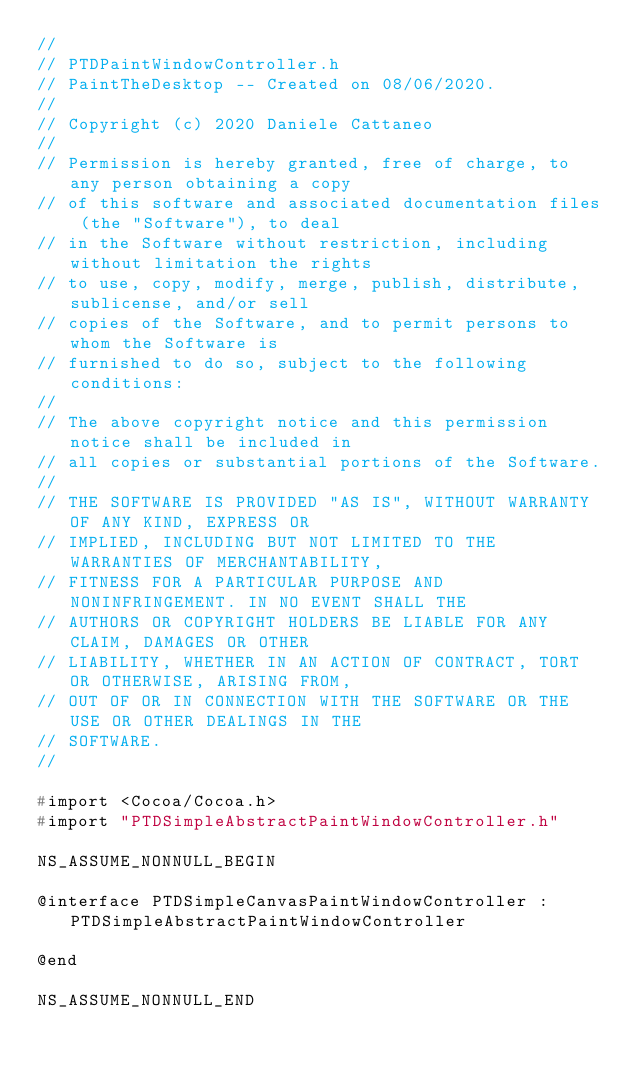Convert code to text. <code><loc_0><loc_0><loc_500><loc_500><_C_>//
// PTDPaintWindowController.h
// PaintTheDesktop -- Created on 08/06/2020.
//
// Copyright (c) 2020 Daniele Cattaneo
//
// Permission is hereby granted, free of charge, to any person obtaining a copy
// of this software and associated documentation files (the "Software"), to deal
// in the Software without restriction, including without limitation the rights
// to use, copy, modify, merge, publish, distribute, sublicense, and/or sell
// copies of the Software, and to permit persons to whom the Software is
// furnished to do so, subject to the following conditions:
//
// The above copyright notice and this permission notice shall be included in
// all copies or substantial portions of the Software.
//
// THE SOFTWARE IS PROVIDED "AS IS", WITHOUT WARRANTY OF ANY KIND, EXPRESS OR
// IMPLIED, INCLUDING BUT NOT LIMITED TO THE WARRANTIES OF MERCHANTABILITY,
// FITNESS FOR A PARTICULAR PURPOSE AND NONINFRINGEMENT. IN NO EVENT SHALL THE
// AUTHORS OR COPYRIGHT HOLDERS BE LIABLE FOR ANY CLAIM, DAMAGES OR OTHER
// LIABILITY, WHETHER IN AN ACTION OF CONTRACT, TORT OR OTHERWISE, ARISING FROM,
// OUT OF OR IN CONNECTION WITH THE SOFTWARE OR THE USE OR OTHER DEALINGS IN THE
// SOFTWARE.
//

#import <Cocoa/Cocoa.h>
#import "PTDSimpleAbstractPaintWindowController.h"

NS_ASSUME_NONNULL_BEGIN

@interface PTDSimpleCanvasPaintWindowController : PTDSimpleAbstractPaintWindowController

@end

NS_ASSUME_NONNULL_END
</code> 